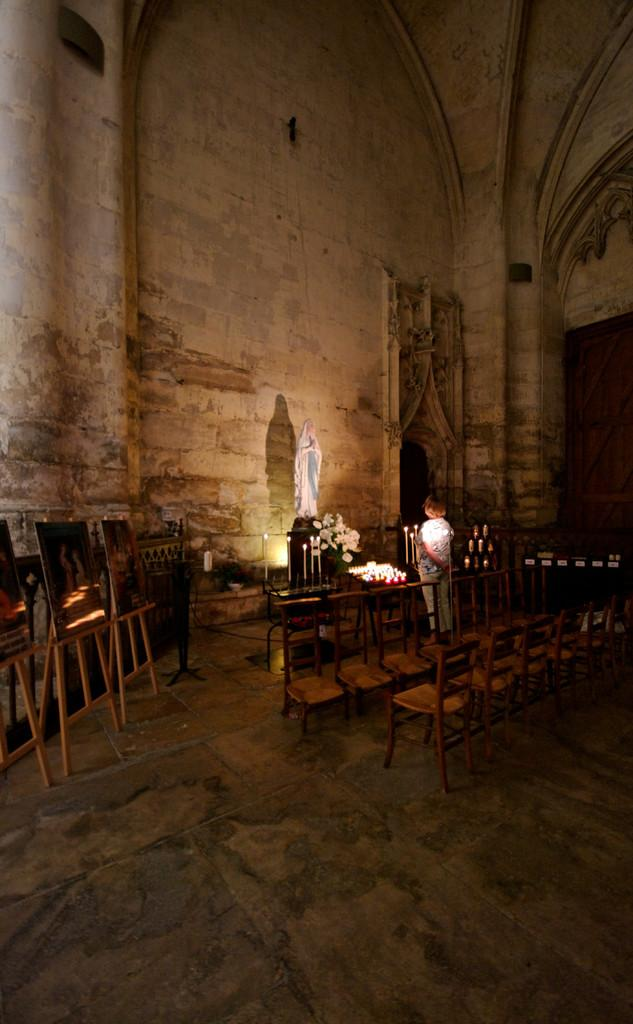What type of furniture is present in the building? There are chairs in the building. Can you describe the person in the building? A person is standing in the building. What objects are in front of the person? There are candles, flowers, and a statue in front of the person. Where are the photo frames located in the building? The photo frames are on the left side of the building. What is the size of the wall behind the photo frames? There is a huge wall behind the photo frames. What type of hand can be seen holding the statue in the image? There is no hand holding the statue in the image; the statue is standing on its own. Is there a veil covering the flowers in the image? There is no veil present in the image; the flowers are visible without any covering. 